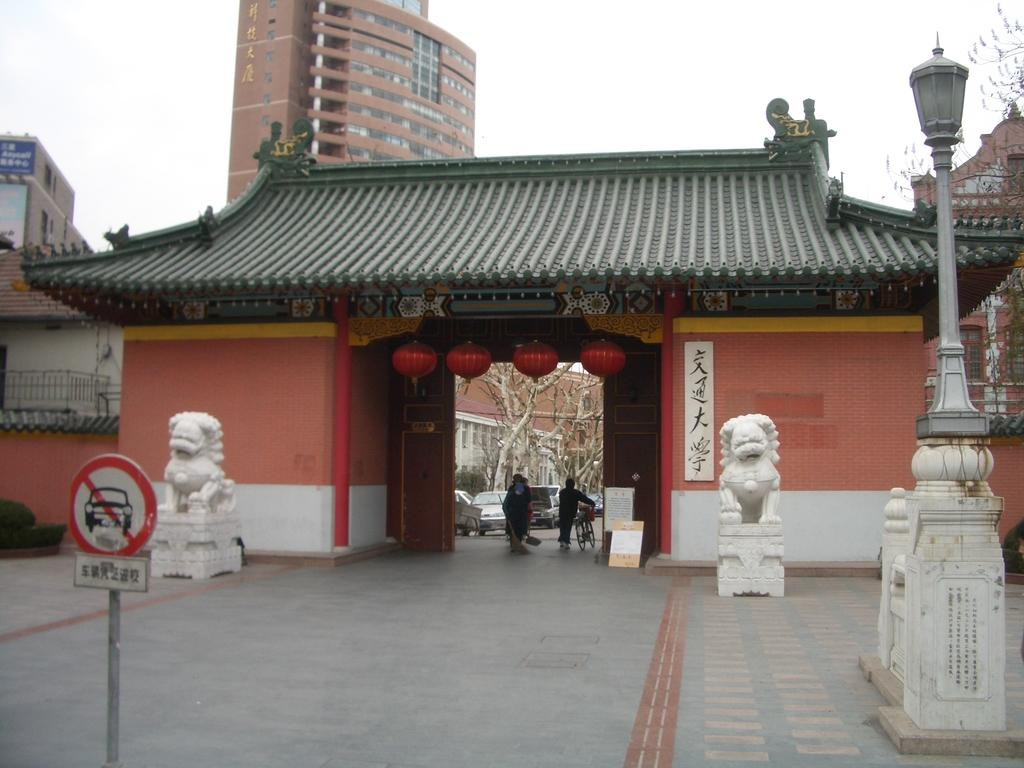What type of structures can be seen in the image? There are buildings in the image. Where are the people located in the image? The people are under an arch in the image. What other objects or features can be seen in the image? There are statues, poles with lights, and boards on the poles in the image. What type of lettuce is being used to decorate the statues in the image? There is no lettuce present in the image; it features buildings, people, statues, poles with lights, and boards on the poles. Can you tell me how many fangs are visible on the statues in the image? There are no fangs visible on the statues in the image. 